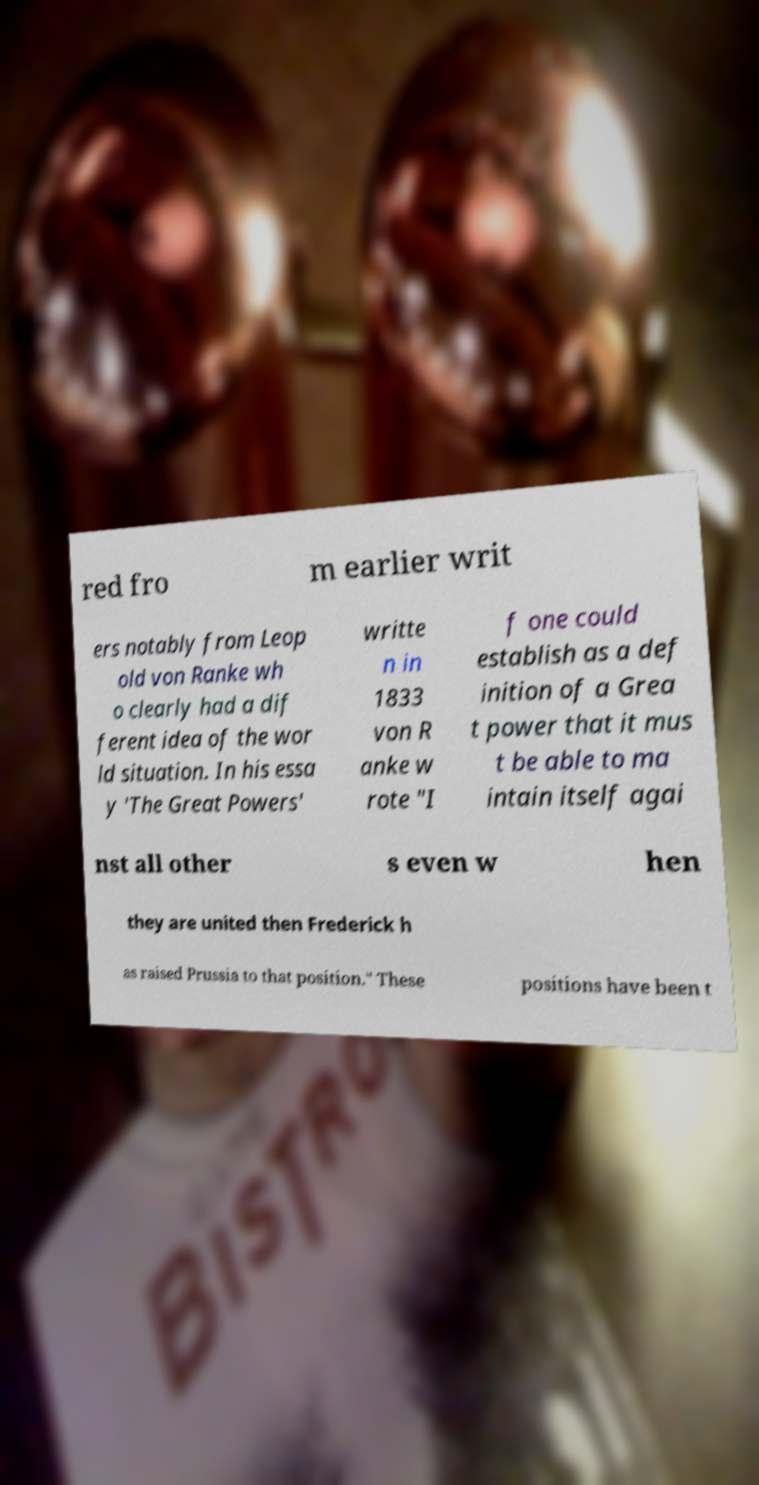Can you accurately transcribe the text from the provided image for me? red fro m earlier writ ers notably from Leop old von Ranke wh o clearly had a dif ferent idea of the wor ld situation. In his essa y 'The Great Powers' writte n in 1833 von R anke w rote "I f one could establish as a def inition of a Grea t power that it mus t be able to ma intain itself agai nst all other s even w hen they are united then Frederick h as raised Prussia to that position." These positions have been t 